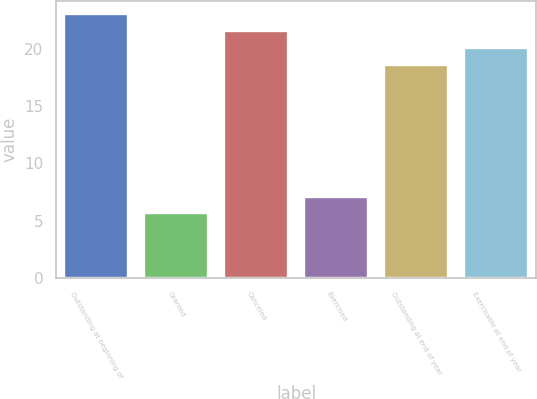Convert chart. <chart><loc_0><loc_0><loc_500><loc_500><bar_chart><fcel>Outstanding at beginning of<fcel>Granted<fcel>Canceled<fcel>Exercised<fcel>Outstanding at end of year<fcel>Exercisable at end of year<nl><fcel>23.02<fcel>5.62<fcel>21.54<fcel>7.1<fcel>18.58<fcel>20.06<nl></chart> 